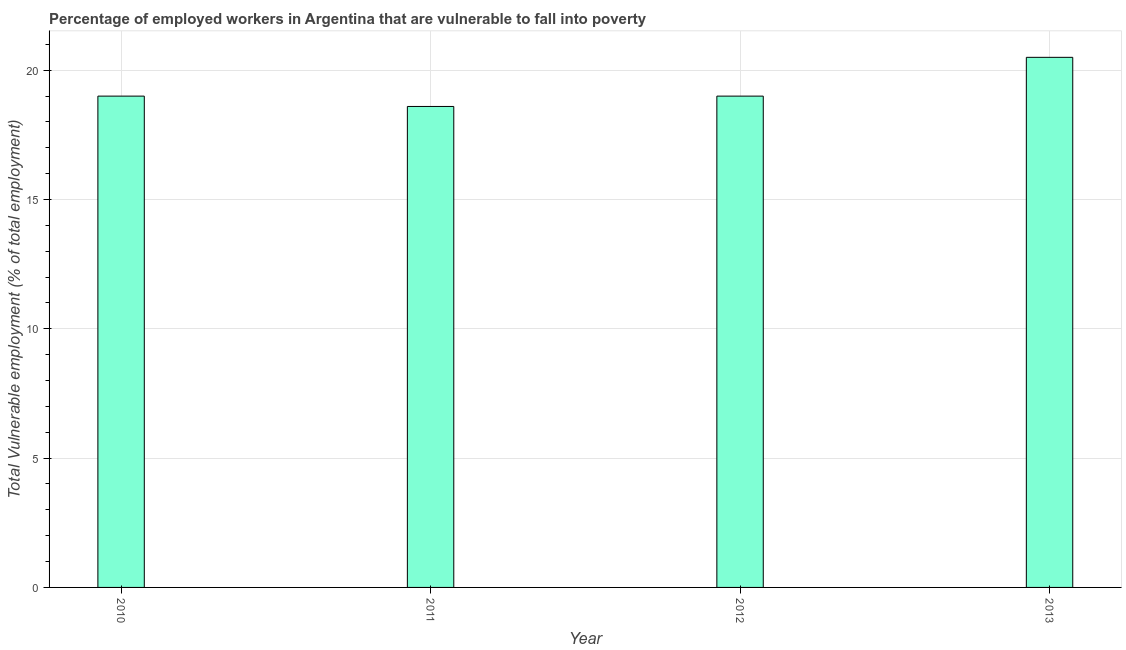What is the title of the graph?
Make the answer very short. Percentage of employed workers in Argentina that are vulnerable to fall into poverty. What is the label or title of the Y-axis?
Offer a terse response. Total Vulnerable employment (% of total employment). Across all years, what is the minimum total vulnerable employment?
Your answer should be compact. 18.6. In which year was the total vulnerable employment minimum?
Your answer should be very brief. 2011. What is the sum of the total vulnerable employment?
Keep it short and to the point. 77.1. What is the difference between the total vulnerable employment in 2011 and 2013?
Your response must be concise. -1.9. What is the average total vulnerable employment per year?
Offer a very short reply. 19.27. Is the difference between the total vulnerable employment in 2010 and 2013 greater than the difference between any two years?
Give a very brief answer. No. What is the difference between the highest and the second highest total vulnerable employment?
Your answer should be very brief. 1.5. Is the sum of the total vulnerable employment in 2011 and 2013 greater than the maximum total vulnerable employment across all years?
Keep it short and to the point. Yes. In how many years, is the total vulnerable employment greater than the average total vulnerable employment taken over all years?
Give a very brief answer. 1. How many bars are there?
Provide a short and direct response. 4. How many years are there in the graph?
Offer a terse response. 4. What is the Total Vulnerable employment (% of total employment) of 2011?
Your answer should be very brief. 18.6. What is the Total Vulnerable employment (% of total employment) in 2012?
Your answer should be very brief. 19. What is the Total Vulnerable employment (% of total employment) in 2013?
Give a very brief answer. 20.5. What is the difference between the Total Vulnerable employment (% of total employment) in 2010 and 2012?
Offer a terse response. 0. What is the difference between the Total Vulnerable employment (% of total employment) in 2010 and 2013?
Keep it short and to the point. -1.5. What is the difference between the Total Vulnerable employment (% of total employment) in 2011 and 2013?
Your answer should be very brief. -1.9. What is the ratio of the Total Vulnerable employment (% of total employment) in 2010 to that in 2013?
Your answer should be very brief. 0.93. What is the ratio of the Total Vulnerable employment (% of total employment) in 2011 to that in 2013?
Offer a terse response. 0.91. What is the ratio of the Total Vulnerable employment (% of total employment) in 2012 to that in 2013?
Give a very brief answer. 0.93. 